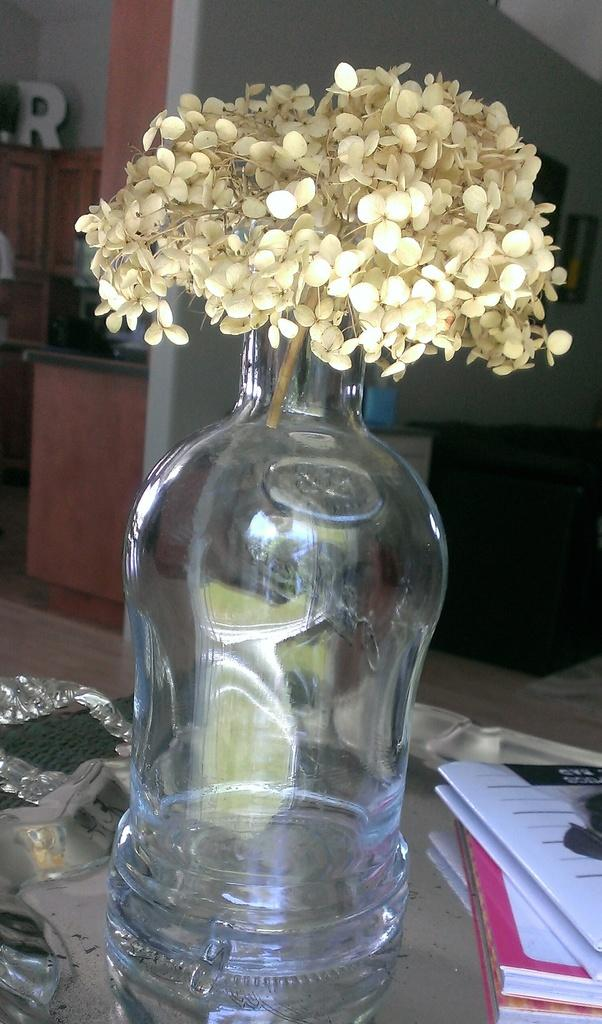What object is in the image that can hold flowers? There is a vase in the image that can hold flowers. How many flowers are in the vase? The vase contains many flowers. What other objects are near the vase in the image? There are books beside the vase. What type of feast is being prepared on the stove in the image? There is no stove present in the image, so it is not possible to determine if a feast is being prepared. 